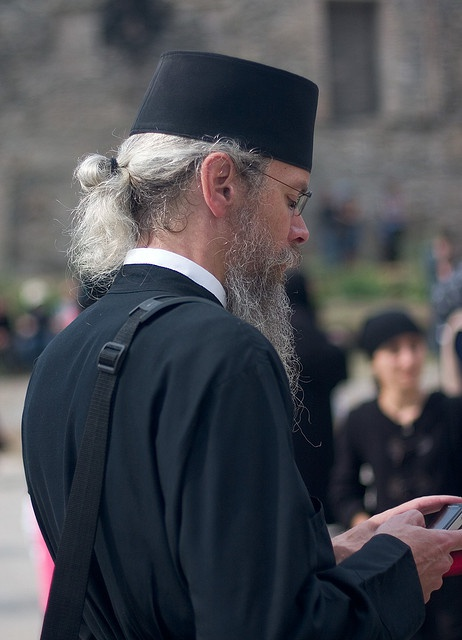Describe the objects in this image and their specific colors. I can see people in gray, black, navy, and darkgray tones, people in gray, black, and tan tones, handbag in gray, black, and darkblue tones, people in gray and darkgray tones, and cell phone in gray and black tones in this image. 